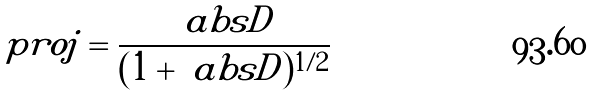Convert formula to latex. <formula><loc_0><loc_0><loc_500><loc_500>\ p r o j = \frac { \ a b s { D } } { ( 1 + \ a b s { D } ) ^ { 1 / 2 } }</formula> 